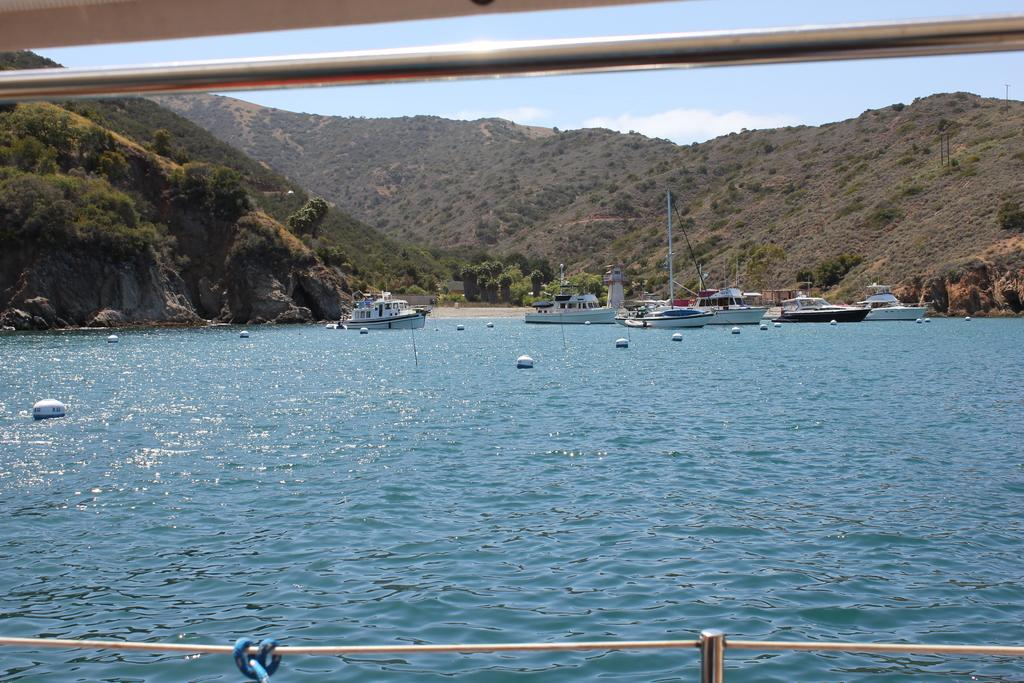What is the main subject of the image? The main subject of the image is a boat. What type of landscape can be seen in the image? Hills are present in the image. What is the boat situated on or in? Water is visible in the image, so the boat is likely on or in the water. What is visible at the top of the image? The sky is visible at the top of the image. What type of knee injury can be seen in the image? There is no knee injury present in the image; it features a boat, hills, water, and the sky. 